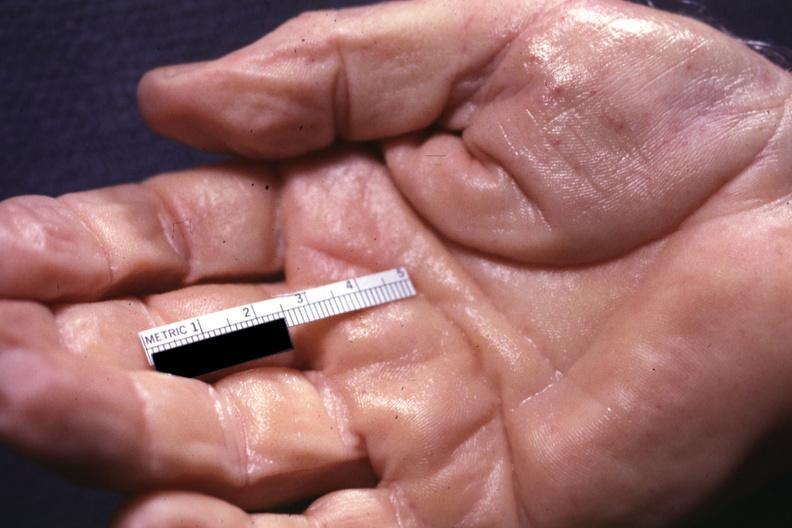what is present?
Answer the question using a single word or phrase. No 